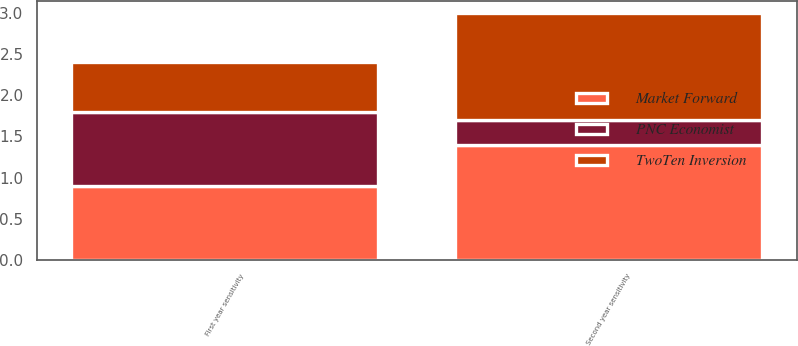<chart> <loc_0><loc_0><loc_500><loc_500><stacked_bar_chart><ecel><fcel>First year sensitivity<fcel>Second year sensitivity<nl><fcel>Market Forward<fcel>0.9<fcel>1.4<nl><fcel>TwoTen Inversion<fcel>0.6<fcel>1.3<nl><fcel>PNC Economist<fcel>0.9<fcel>0.3<nl></chart> 